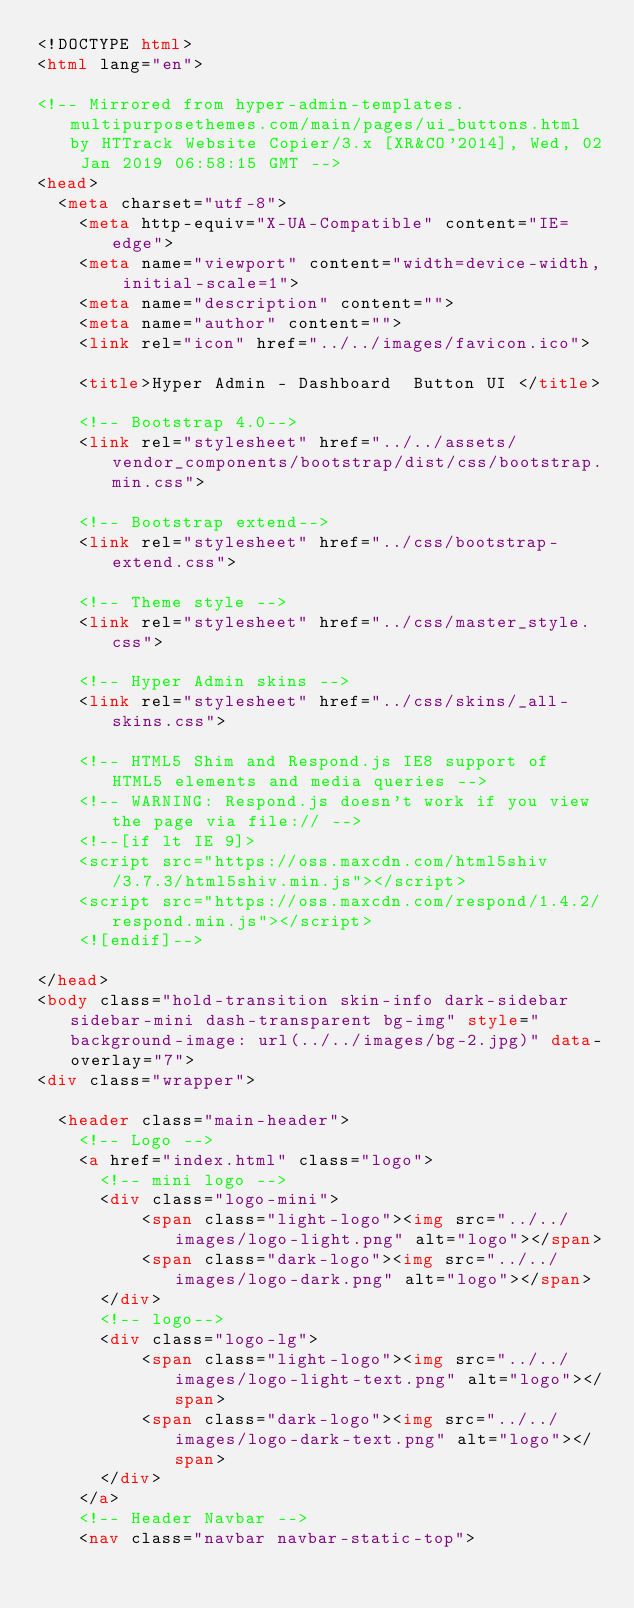Convert code to text. <code><loc_0><loc_0><loc_500><loc_500><_HTML_><!DOCTYPE html>
<html lang="en">

<!-- Mirrored from hyper-admin-templates.multipurposethemes.com/main/pages/ui_buttons.html by HTTrack Website Copier/3.x [XR&CO'2014], Wed, 02 Jan 2019 06:58:15 GMT -->
<head>
  <meta charset="utf-8">
    <meta http-equiv="X-UA-Compatible" content="IE=edge">
    <meta name="viewport" content="width=device-width, initial-scale=1">
    <meta name="description" content="">
    <meta name="author" content="">
    <link rel="icon" href="../../images/favicon.ico">

    <title>Hyper Admin - Dashboard  Button UI </title>
  
	<!-- Bootstrap 4.0-->
	<link rel="stylesheet" href="../../assets/vendor_components/bootstrap/dist/css/bootstrap.min.css">
	
	<!-- Bootstrap extend-->
	<link rel="stylesheet" href="../css/bootstrap-extend.css">

	<!-- Theme style -->
	<link rel="stylesheet" href="../css/master_style.css">

	<!-- Hyper Admin skins -->
	<link rel="stylesheet" href="../css/skins/_all-skins.css">

	<!-- HTML5 Shim and Respond.js IE8 support of HTML5 elements and media queries -->
	<!-- WARNING: Respond.js doesn't work if you view the page via file:// -->
	<!--[if lt IE 9]>
	<script src="https://oss.maxcdn.com/html5shiv/3.7.3/html5shiv.min.js"></script>
	<script src="https://oss.maxcdn.com/respond/1.4.2/respond.min.js"></script>
	<![endif]-->
	
</head>
<body class="hold-transition skin-info dark-sidebar sidebar-mini dash-transparent bg-img" style="background-image: url(../../images/bg-2.jpg)" data-overlay="7">
<div class="wrapper">

  <header class="main-header">
    <!-- Logo -->
    <a href="index.html" class="logo">
      <!-- mini logo -->
	  <div class="logo-mini">
		  <span class="light-logo"><img src="../../images/logo-light.png" alt="logo"></span>
		  <span class="dark-logo"><img src="../../images/logo-dark.png" alt="logo"></span>
	  </div>
      <!-- logo-->
      <div class="logo-lg">
		  <span class="light-logo"><img src="../../images/logo-light-text.png" alt="logo"></span>
	  	  <span class="dark-logo"><img src="../../images/logo-dark-text.png" alt="logo"></span>
	  </div>
    </a>
    <!-- Header Navbar -->
    <nav class="navbar navbar-static-top"></code> 